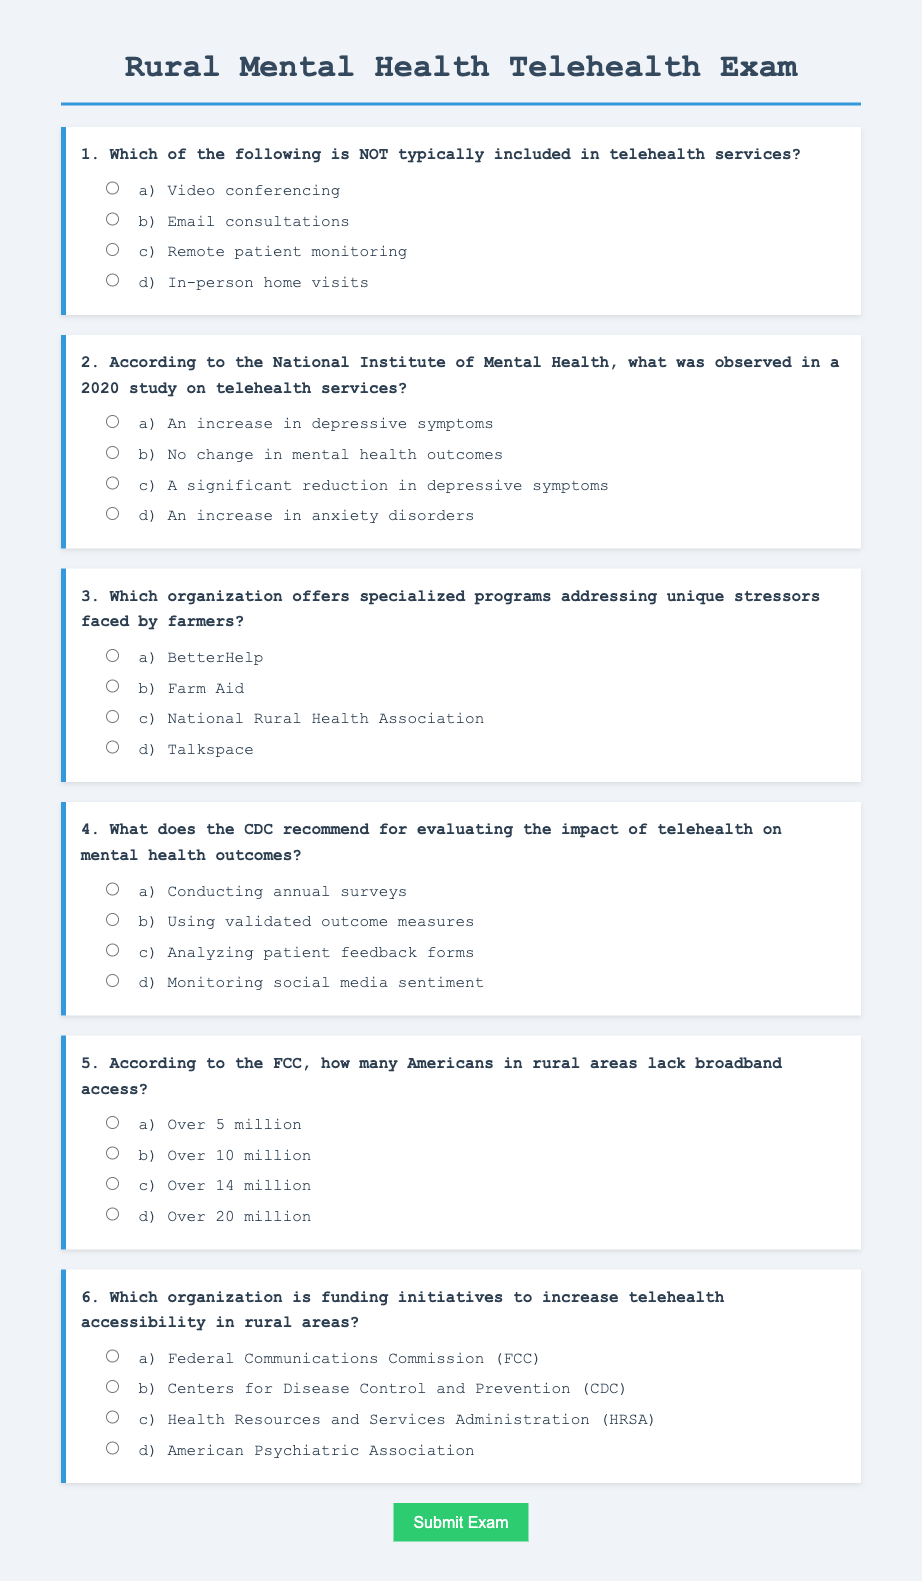What is the main topic of the exam? The main topic of the exam is evaluating telehealth solutions for rural mental health, specifically focusing on remote counseling and support networks.
Answer: Evaluating telehealth solutions for rural mental health Which telehealth service is NOT typically included? The question asks to identify the service that is not part of typical telehealth services; the options indicate that in-person home visits are the outlier.
Answer: In-person home visits What significant observation was made in the 2020 study on telehealth services? The question refers to findings stated in the exam options regarding mental health outcomes related to telehealth services, highlighting a significant reduction in depressive symptoms.
Answer: A significant reduction in depressive symptoms Which organization addresses stressors faced by farmers? The question seeks to identify from the options provided the organization that specifically offers programs for farmers experiencing unique stressors.
Answer: Farm Aid What method does the CDC recommend for evaluating telehealth impact? The focus is on understanding the CDC's suggestion for assessing the effectiveness of telehealth, selecting the method of using validated outcome measures.
Answer: Using validated outcome measures How many Americans in rural areas lack broadband access? The question collects specific numerical data related to broadband access issues in rural America as reported by the FCC.
Answer: Over 14 million Which organization funds initiatives for telehealth accessibility? The goal is to find which agency specifically finances efforts to improve telehealth access in rural settings, among the provided options.
Answer: Health Resources and Services Administration (HRSA) 